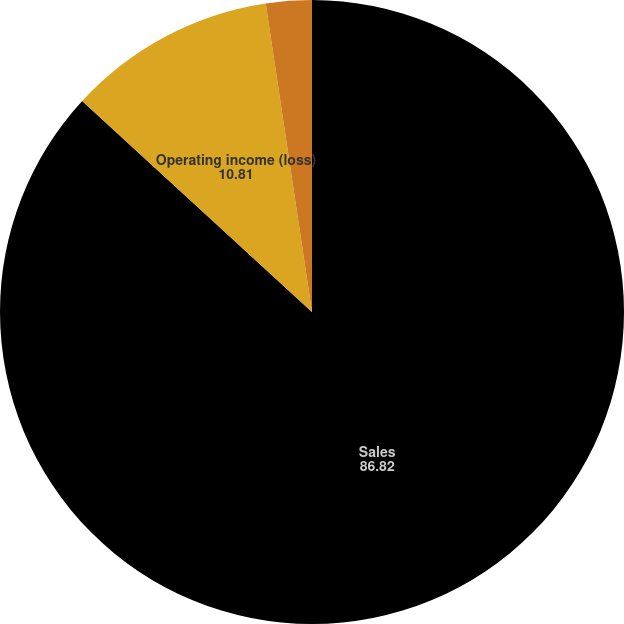Convert chart to OTSL. <chart><loc_0><loc_0><loc_500><loc_500><pie_chart><fcel>Sales<fcel>Operating income (loss)<fcel>Adjusted EBITDA<nl><fcel>86.82%<fcel>10.81%<fcel>2.37%<nl></chart> 